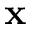Convert formula to latex. <formula><loc_0><loc_0><loc_500><loc_500>x</formula> 